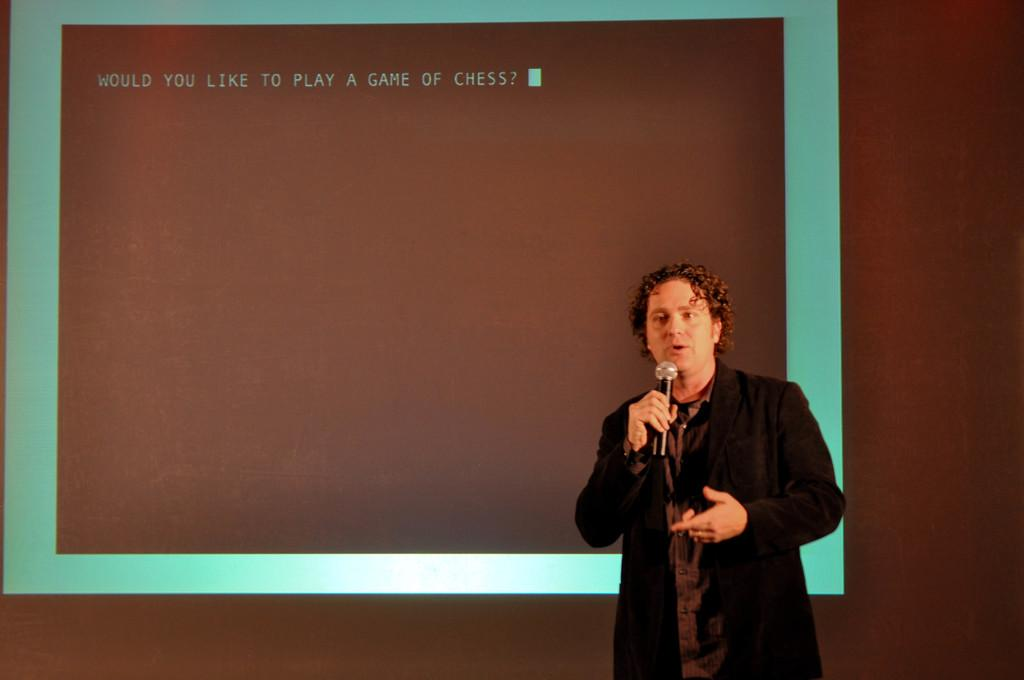Who is present in the image? There is a man in the image. What is the man wearing? The man is wearing a black coat. What is the man holding in the image? The man is holding a mic. What can be seen on the big screen in the image? There is text on the big screen in the image. What type of boot is the man wearing in the image? The man is not wearing a boot in the image; he is wearing a black coat. Is the man experiencing any pain in the image? There is no indication of pain in the image; it only shows a man holding a mic and wearing a black coat. 